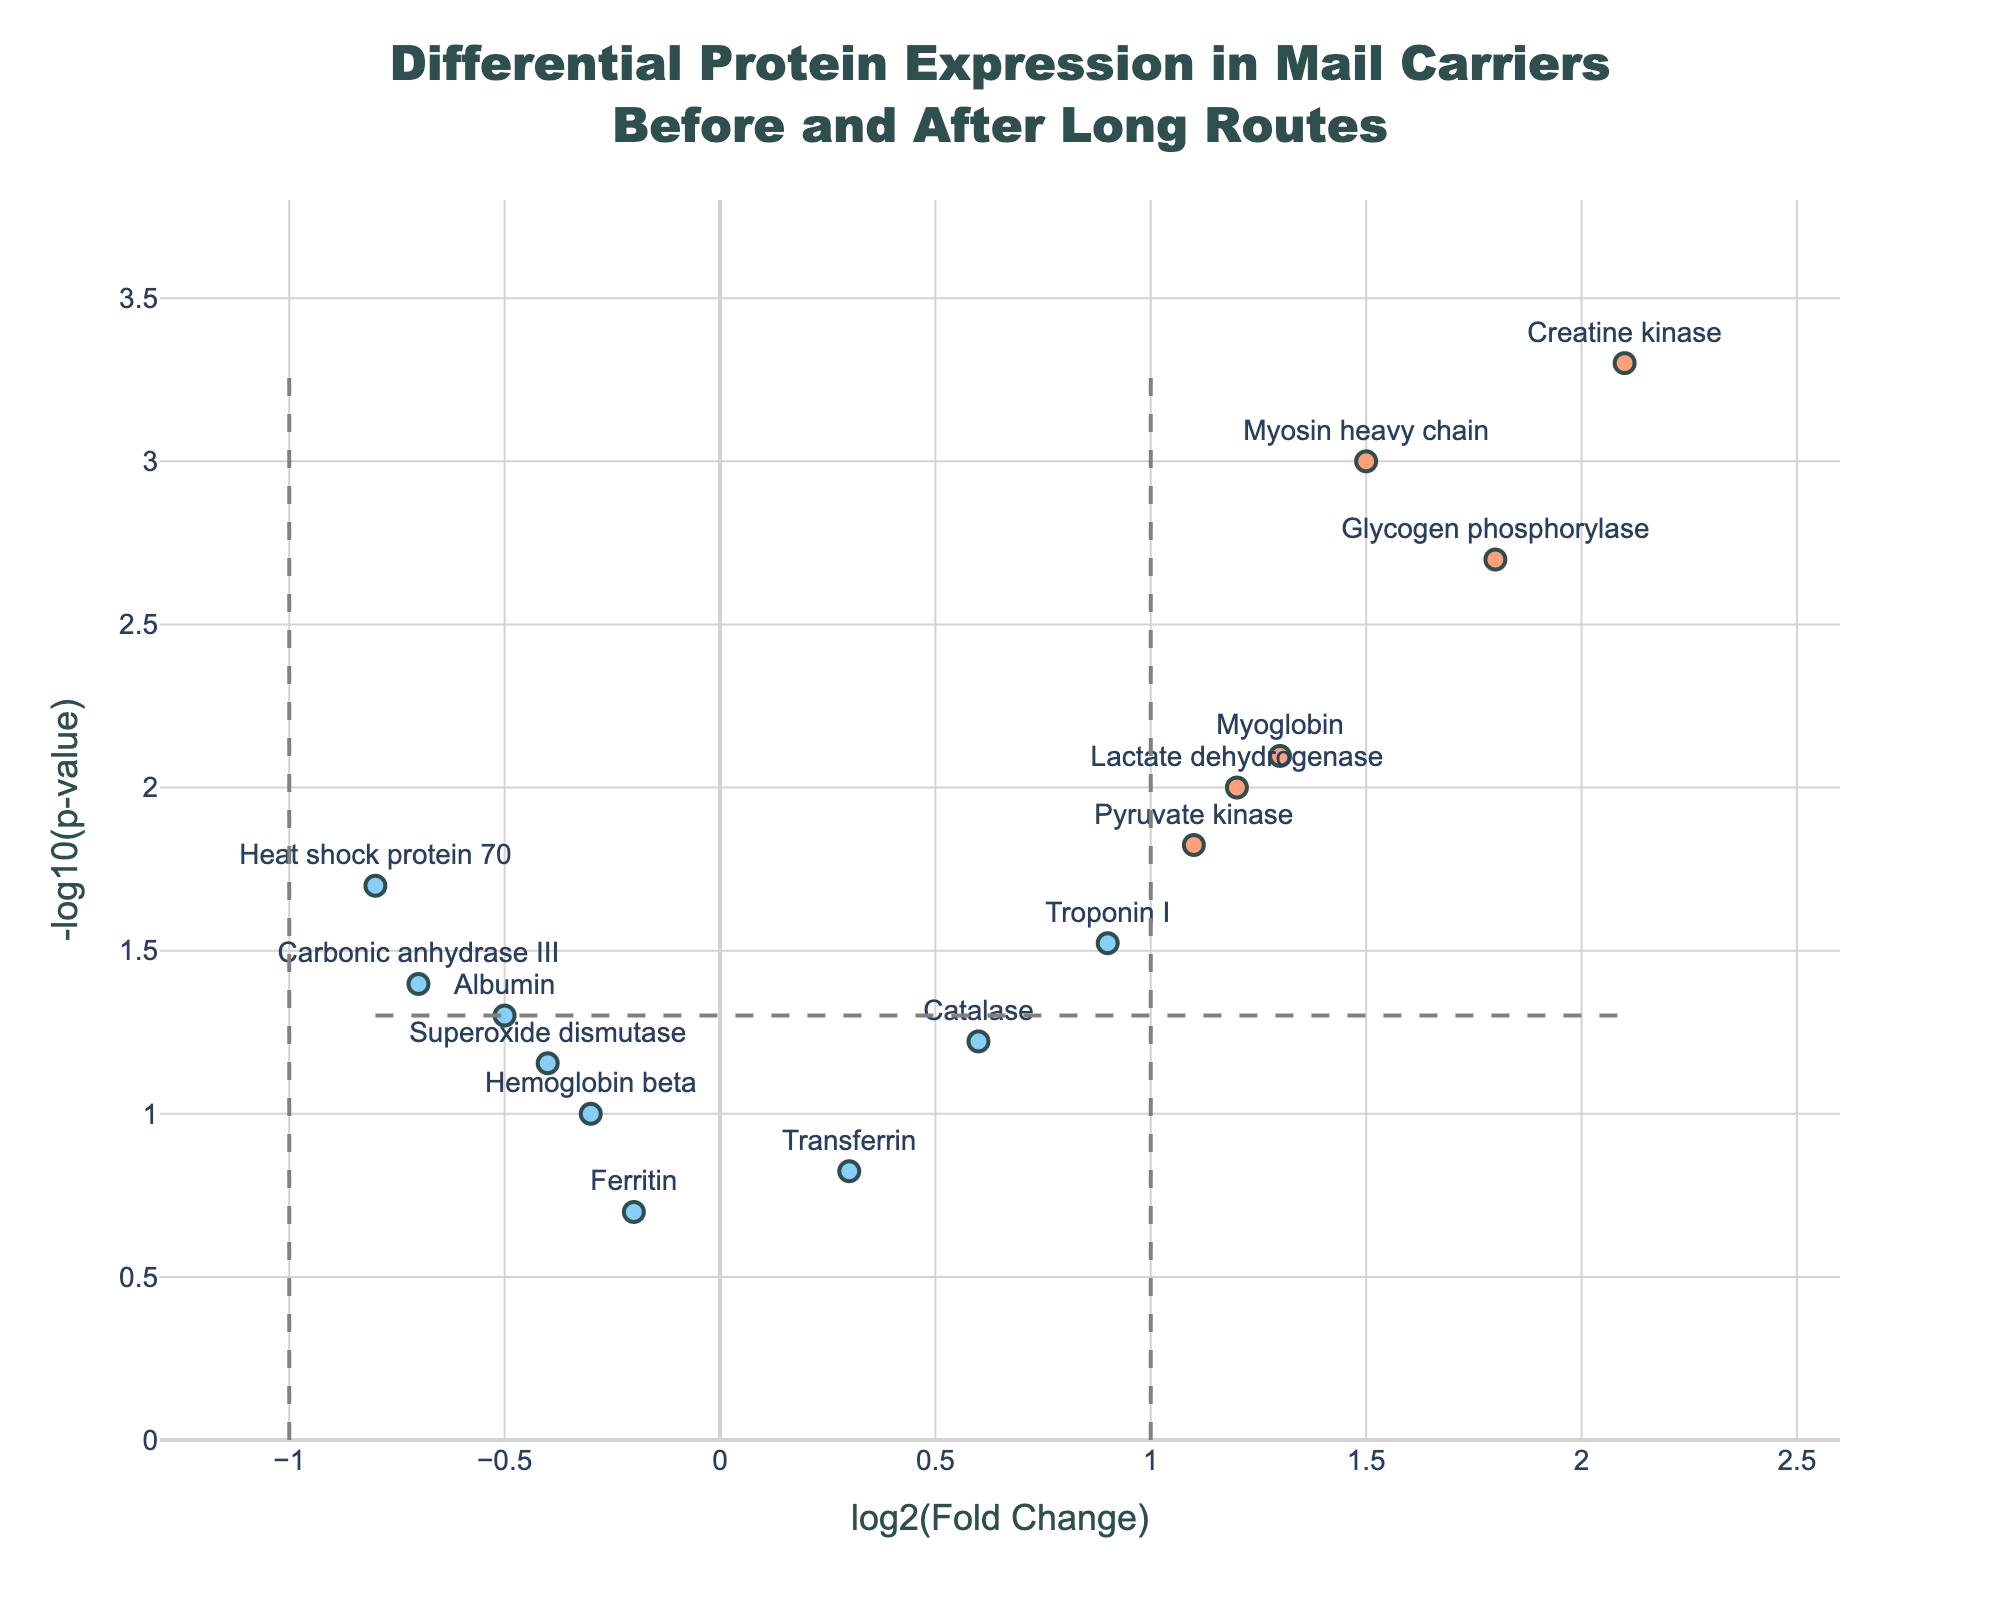How many proteins show a log2 fold change greater than 1? Identify the data points where the x-axis value (log2FoldChange) is greater than 1. Count these points.
Answer: Six proteins (Myosin heavy chain, Creatine kinase, Lactate dehydrogenase, Glycogen phosphorylase, Pyruvate kinase, Myoglobin) How many proteins have a p-value lower than 0.05? Identify the data points where the y-axis value (representing -log10(pValue)) is greater than -log10(0.05). Count these points.
Answer: Nine proteins (Myosin heavy chain, Heat shock protein 70, Creatine kinase, Lactate dehydrogenase, Troponin I, Glycogen phosphorylase, Pyruvate kinase, Myoglobin, Carbonic anhydrase III) Which protein has the highest log2 fold change? Locate the data point with the highest value on the x-axis (log2FoldChange) and check its corresponding protein label.
Answer: Creatine kinase Are there any proteins with a negative log2 fold change and a p-value lower than 0.05? Look for data points where the x-axis value (log2FoldChange) is less than zero and the y-axis value (representing -log10(pValue)) is greater than -log10(0.05).
Answer: Yes, two proteins (Heat shock protein 70, Carbonic anhydrase III) Which protein has the lowest p-value? Identify the data point that is highest on the y-axis (representing the smallest p-value) and check its corresponding protein label.
Answer: Creatine kinase How many proteins have both a log2 fold change greater than 1 and a p-value below 0.05? Identify data points that meet both criteria: x-axis value (log2FoldChange) greater than 1 and y-axis value (representing -log10(pValue)) above -log10(0.05). Count these points.
Answer: Five proteins (Myosin heavy chain, Creatine kinase, Lactate dehydrogenase, Glycogen phosphorylase, Myoglobin) Which proteins have a log2 fold change between 0 and 1 and a p-value lower than 0.05? Identify data points where the x-axis value (log2FoldChange) is between 0 and 1 and the y-axis value (representing -log10(pValue)) is greater than -log10(0.05). Check their corresponding protein labels.
Answer: Troponin I Are there more upregulated proteins (positive log2 fold change) or downregulated proteins (negative log2 fold change)? Count the number of data points where the x-axis value is positive and compare it with the number of points where the x-axis value is negative.
Answer: More upregulated proteins (8 upregulated, 7 downregulated) What is the approximate p-value for Myosin heavy chain? Check the y-axis value (representing -log10(pValue)) for Myosin heavy chain and convert it back to the p-value using the formula 10^(-value).
Answer: 0.001 What's the difference in log2 fold change between Creatine kinase and Heat shock protein 70? Find the log2FoldChange values for Creatine kinase and Heat shock protein 70. Calculate the difference by subtracting the value for Heat shock protein 70 from Creatine kinase.
Answer: 2.9 